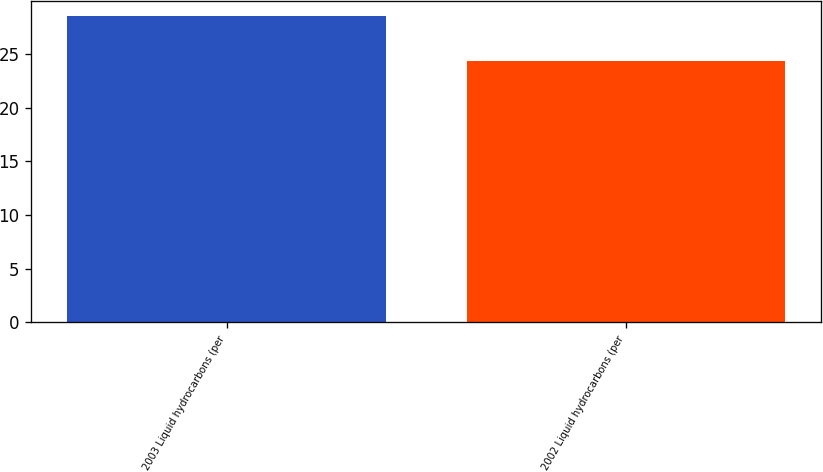Convert chart. <chart><loc_0><loc_0><loc_500><loc_500><bar_chart><fcel>2003 Liquid hydrocarbons (per<fcel>2002 Liquid hydrocarbons (per<nl><fcel>28.5<fcel>24.4<nl></chart> 